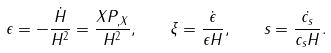Convert formula to latex. <formula><loc_0><loc_0><loc_500><loc_500>\epsilon = - \frac { \dot { H } } { H ^ { 2 } } = \frac { X P _ { , X } } { H ^ { 2 } } , \quad \xi = \frac { \dot { \epsilon } } { \epsilon H } , \quad s = \frac { \dot { c _ { s } } } { c _ { s } H } .</formula> 